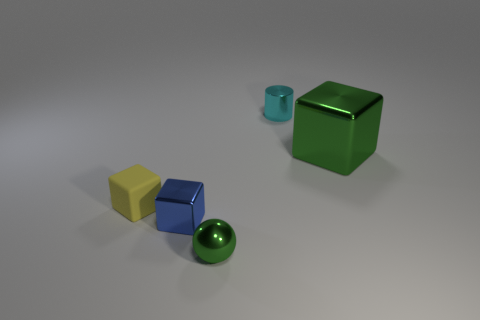What materials are the objects in the image likely made of, and how can you tell? The objects in the image seem to be made of different materials. The cube with the reflective surface hints at being metallic, possibly steel or aluminum, due to its shine and clear reflections. The sphere also appears glossy, suggesting a polished ceramic or plastic. The two matte cubes, one yellow and one blue, along with the small cylinder, likely consist of a plastic or painted wood with a non-glossy finish, judged by the lack of reflection and the even diffusion of light on their surfaces. 